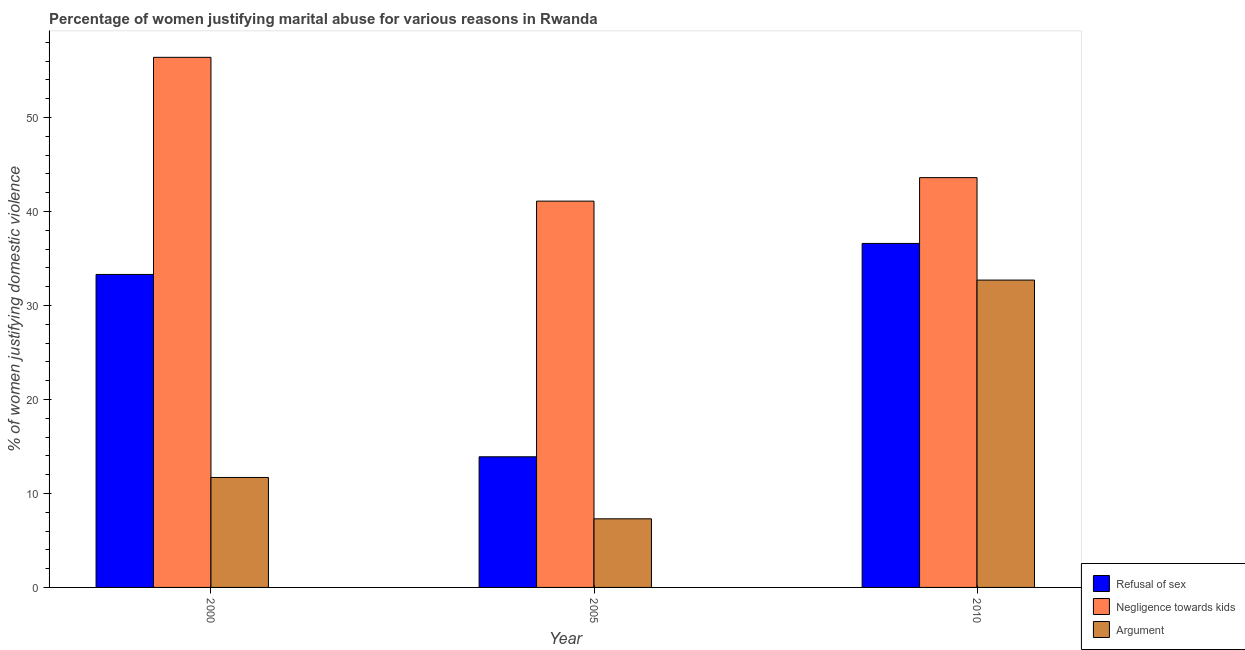How many bars are there on the 2nd tick from the right?
Provide a short and direct response. 3. What is the label of the 1st group of bars from the left?
Offer a very short reply. 2000. In how many cases, is the number of bars for a given year not equal to the number of legend labels?
Keep it short and to the point. 0. What is the percentage of women justifying domestic violence due to refusal of sex in 2010?
Offer a terse response. 36.6. Across all years, what is the maximum percentage of women justifying domestic violence due to negligence towards kids?
Your answer should be very brief. 56.4. In which year was the percentage of women justifying domestic violence due to refusal of sex maximum?
Your answer should be very brief. 2010. What is the total percentage of women justifying domestic violence due to arguments in the graph?
Make the answer very short. 51.7. What is the difference between the percentage of women justifying domestic violence due to refusal of sex in 2000 and that in 2010?
Offer a very short reply. -3.3. What is the difference between the percentage of women justifying domestic violence due to refusal of sex in 2000 and the percentage of women justifying domestic violence due to negligence towards kids in 2005?
Provide a short and direct response. 19.4. What is the average percentage of women justifying domestic violence due to refusal of sex per year?
Your response must be concise. 27.93. In how many years, is the percentage of women justifying domestic violence due to refusal of sex greater than 42 %?
Give a very brief answer. 0. What is the ratio of the percentage of women justifying domestic violence due to arguments in 2000 to that in 2010?
Offer a very short reply. 0.36. Is the percentage of women justifying domestic violence due to negligence towards kids in 2000 less than that in 2010?
Provide a succinct answer. No. What is the difference between the highest and the second highest percentage of women justifying domestic violence due to negligence towards kids?
Ensure brevity in your answer.  12.8. What is the difference between the highest and the lowest percentage of women justifying domestic violence due to arguments?
Make the answer very short. 25.4. In how many years, is the percentage of women justifying domestic violence due to negligence towards kids greater than the average percentage of women justifying domestic violence due to negligence towards kids taken over all years?
Offer a very short reply. 1. What does the 2nd bar from the left in 2010 represents?
Provide a short and direct response. Negligence towards kids. What does the 2nd bar from the right in 2005 represents?
Offer a terse response. Negligence towards kids. Is it the case that in every year, the sum of the percentage of women justifying domestic violence due to refusal of sex and percentage of women justifying domestic violence due to negligence towards kids is greater than the percentage of women justifying domestic violence due to arguments?
Provide a succinct answer. Yes. How many bars are there?
Keep it short and to the point. 9. What is the difference between two consecutive major ticks on the Y-axis?
Give a very brief answer. 10. Are the values on the major ticks of Y-axis written in scientific E-notation?
Offer a very short reply. No. How many legend labels are there?
Give a very brief answer. 3. How are the legend labels stacked?
Make the answer very short. Vertical. What is the title of the graph?
Offer a terse response. Percentage of women justifying marital abuse for various reasons in Rwanda. What is the label or title of the Y-axis?
Provide a short and direct response. % of women justifying domestic violence. What is the % of women justifying domestic violence in Refusal of sex in 2000?
Keep it short and to the point. 33.3. What is the % of women justifying domestic violence of Negligence towards kids in 2000?
Give a very brief answer. 56.4. What is the % of women justifying domestic violence of Refusal of sex in 2005?
Provide a succinct answer. 13.9. What is the % of women justifying domestic violence in Negligence towards kids in 2005?
Keep it short and to the point. 41.1. What is the % of women justifying domestic violence of Refusal of sex in 2010?
Provide a succinct answer. 36.6. What is the % of women justifying domestic violence in Negligence towards kids in 2010?
Give a very brief answer. 43.6. What is the % of women justifying domestic violence of Argument in 2010?
Your answer should be very brief. 32.7. Across all years, what is the maximum % of women justifying domestic violence of Refusal of sex?
Your answer should be compact. 36.6. Across all years, what is the maximum % of women justifying domestic violence of Negligence towards kids?
Ensure brevity in your answer.  56.4. Across all years, what is the maximum % of women justifying domestic violence of Argument?
Keep it short and to the point. 32.7. Across all years, what is the minimum % of women justifying domestic violence of Negligence towards kids?
Your answer should be very brief. 41.1. Across all years, what is the minimum % of women justifying domestic violence of Argument?
Your response must be concise. 7.3. What is the total % of women justifying domestic violence of Refusal of sex in the graph?
Your response must be concise. 83.8. What is the total % of women justifying domestic violence of Negligence towards kids in the graph?
Make the answer very short. 141.1. What is the total % of women justifying domestic violence of Argument in the graph?
Your response must be concise. 51.7. What is the difference between the % of women justifying domestic violence in Negligence towards kids in 2000 and that in 2005?
Provide a short and direct response. 15.3. What is the difference between the % of women justifying domestic violence of Refusal of sex in 2000 and that in 2010?
Make the answer very short. -3.3. What is the difference between the % of women justifying domestic violence in Argument in 2000 and that in 2010?
Make the answer very short. -21. What is the difference between the % of women justifying domestic violence in Refusal of sex in 2005 and that in 2010?
Provide a short and direct response. -22.7. What is the difference between the % of women justifying domestic violence of Negligence towards kids in 2005 and that in 2010?
Make the answer very short. -2.5. What is the difference between the % of women justifying domestic violence in Argument in 2005 and that in 2010?
Provide a succinct answer. -25.4. What is the difference between the % of women justifying domestic violence in Refusal of sex in 2000 and the % of women justifying domestic violence in Negligence towards kids in 2005?
Offer a terse response. -7.8. What is the difference between the % of women justifying domestic violence in Negligence towards kids in 2000 and the % of women justifying domestic violence in Argument in 2005?
Ensure brevity in your answer.  49.1. What is the difference between the % of women justifying domestic violence of Refusal of sex in 2000 and the % of women justifying domestic violence of Negligence towards kids in 2010?
Your answer should be very brief. -10.3. What is the difference between the % of women justifying domestic violence of Refusal of sex in 2000 and the % of women justifying domestic violence of Argument in 2010?
Your answer should be compact. 0.6. What is the difference between the % of women justifying domestic violence of Negligence towards kids in 2000 and the % of women justifying domestic violence of Argument in 2010?
Your response must be concise. 23.7. What is the difference between the % of women justifying domestic violence in Refusal of sex in 2005 and the % of women justifying domestic violence in Negligence towards kids in 2010?
Your answer should be very brief. -29.7. What is the difference between the % of women justifying domestic violence of Refusal of sex in 2005 and the % of women justifying domestic violence of Argument in 2010?
Your answer should be very brief. -18.8. What is the difference between the % of women justifying domestic violence in Negligence towards kids in 2005 and the % of women justifying domestic violence in Argument in 2010?
Ensure brevity in your answer.  8.4. What is the average % of women justifying domestic violence in Refusal of sex per year?
Offer a terse response. 27.93. What is the average % of women justifying domestic violence in Negligence towards kids per year?
Ensure brevity in your answer.  47.03. What is the average % of women justifying domestic violence in Argument per year?
Provide a succinct answer. 17.23. In the year 2000, what is the difference between the % of women justifying domestic violence of Refusal of sex and % of women justifying domestic violence of Negligence towards kids?
Provide a short and direct response. -23.1. In the year 2000, what is the difference between the % of women justifying domestic violence of Refusal of sex and % of women justifying domestic violence of Argument?
Provide a succinct answer. 21.6. In the year 2000, what is the difference between the % of women justifying domestic violence of Negligence towards kids and % of women justifying domestic violence of Argument?
Make the answer very short. 44.7. In the year 2005, what is the difference between the % of women justifying domestic violence of Refusal of sex and % of women justifying domestic violence of Negligence towards kids?
Provide a short and direct response. -27.2. In the year 2005, what is the difference between the % of women justifying domestic violence in Negligence towards kids and % of women justifying domestic violence in Argument?
Provide a short and direct response. 33.8. In the year 2010, what is the difference between the % of women justifying domestic violence of Refusal of sex and % of women justifying domestic violence of Negligence towards kids?
Your response must be concise. -7. In the year 2010, what is the difference between the % of women justifying domestic violence in Refusal of sex and % of women justifying domestic violence in Argument?
Your response must be concise. 3.9. In the year 2010, what is the difference between the % of women justifying domestic violence of Negligence towards kids and % of women justifying domestic violence of Argument?
Offer a terse response. 10.9. What is the ratio of the % of women justifying domestic violence in Refusal of sex in 2000 to that in 2005?
Your answer should be compact. 2.4. What is the ratio of the % of women justifying domestic violence in Negligence towards kids in 2000 to that in 2005?
Offer a very short reply. 1.37. What is the ratio of the % of women justifying domestic violence in Argument in 2000 to that in 2005?
Offer a terse response. 1.6. What is the ratio of the % of women justifying domestic violence of Refusal of sex in 2000 to that in 2010?
Offer a terse response. 0.91. What is the ratio of the % of women justifying domestic violence of Negligence towards kids in 2000 to that in 2010?
Offer a very short reply. 1.29. What is the ratio of the % of women justifying domestic violence of Argument in 2000 to that in 2010?
Ensure brevity in your answer.  0.36. What is the ratio of the % of women justifying domestic violence of Refusal of sex in 2005 to that in 2010?
Offer a terse response. 0.38. What is the ratio of the % of women justifying domestic violence in Negligence towards kids in 2005 to that in 2010?
Provide a short and direct response. 0.94. What is the ratio of the % of women justifying domestic violence of Argument in 2005 to that in 2010?
Offer a terse response. 0.22. What is the difference between the highest and the lowest % of women justifying domestic violence of Refusal of sex?
Give a very brief answer. 22.7. What is the difference between the highest and the lowest % of women justifying domestic violence in Negligence towards kids?
Your response must be concise. 15.3. What is the difference between the highest and the lowest % of women justifying domestic violence in Argument?
Give a very brief answer. 25.4. 